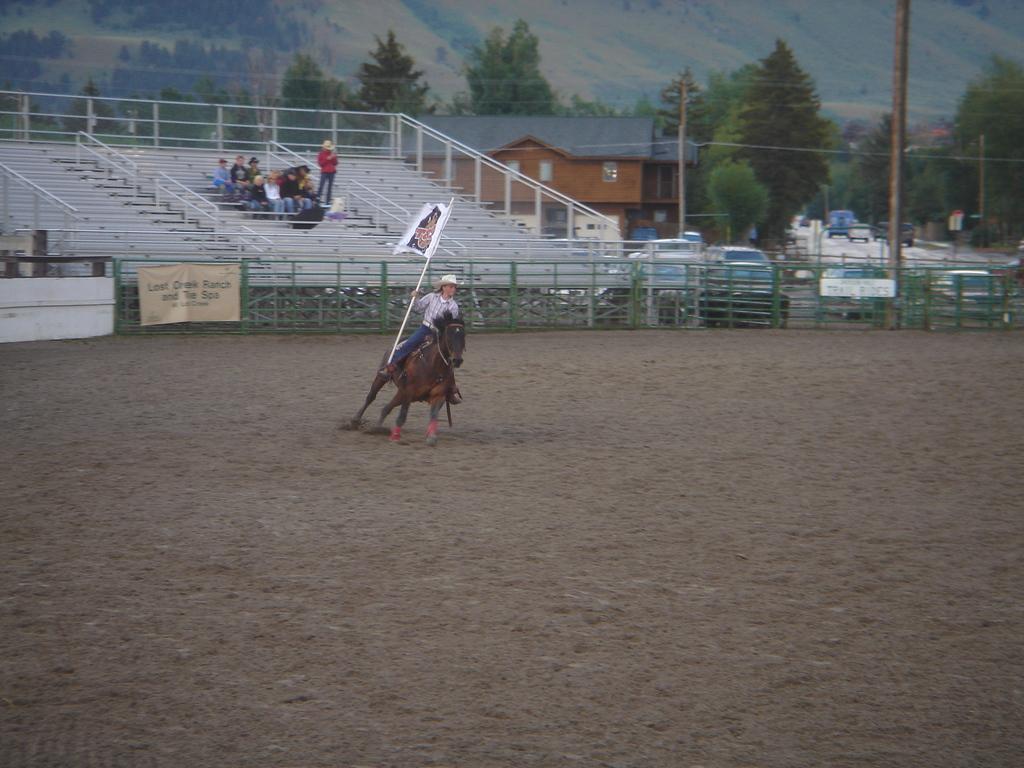Can you describe this image briefly? In this picture I can see a man is riding the horse, he wore hat and also holding a flag in his right hand. At the back side few people are sitting on the stairs and observing this. On the right side there is a house, few cars are parked on the road and there are trees in this image. 